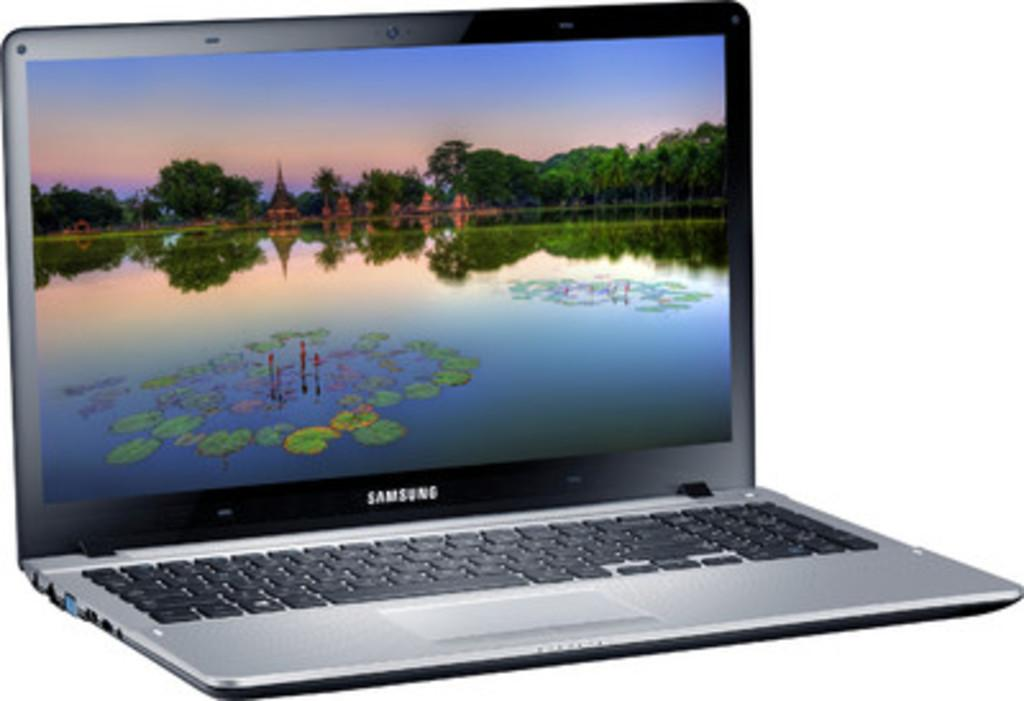<image>
Give a short and clear explanation of the subsequent image. A Samsung laptop displays a nice scene of a lake surrounded by trees. 